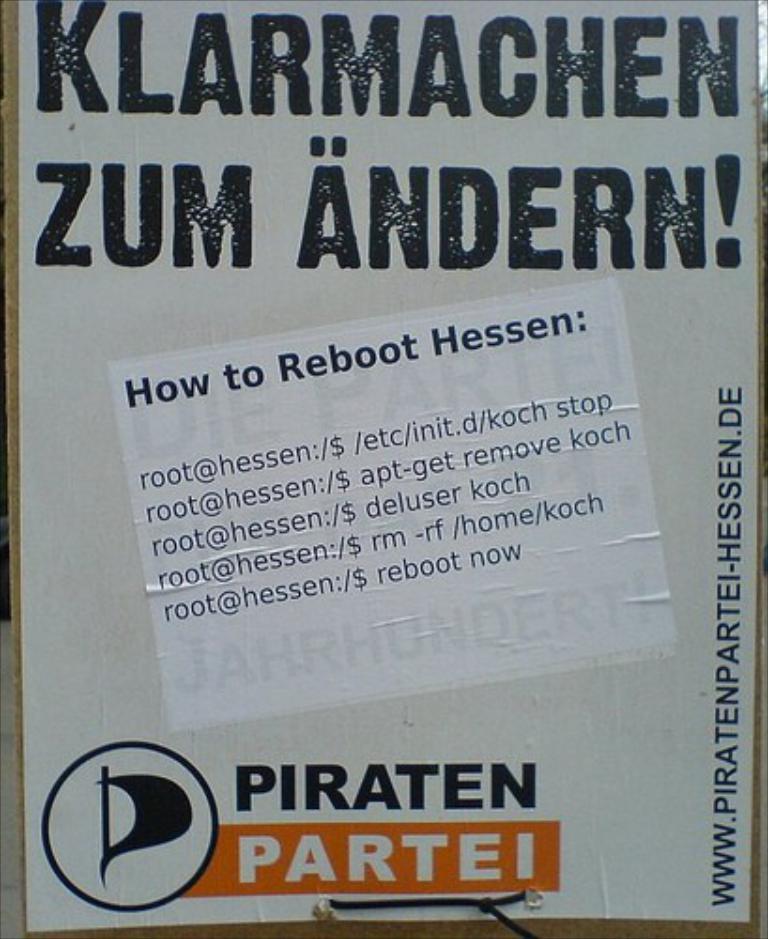What is it telling you to reboot?
Keep it short and to the point. Hessen. What is the title?
Make the answer very short. Klarmachen. 